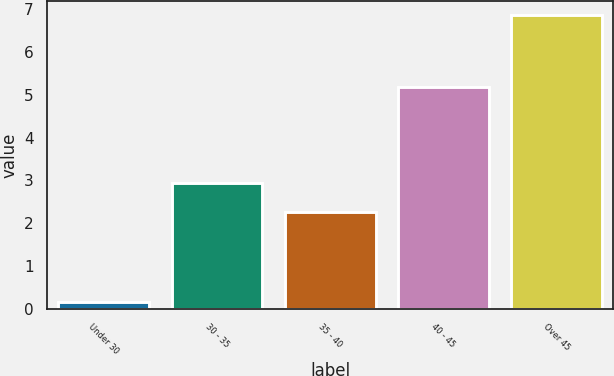<chart> <loc_0><loc_0><loc_500><loc_500><bar_chart><fcel>Under 30<fcel>30 - 35<fcel>35 - 40<fcel>40 - 45<fcel>Over 45<nl><fcel>0.16<fcel>2.93<fcel>2.26<fcel>5.19<fcel>6.85<nl></chart> 